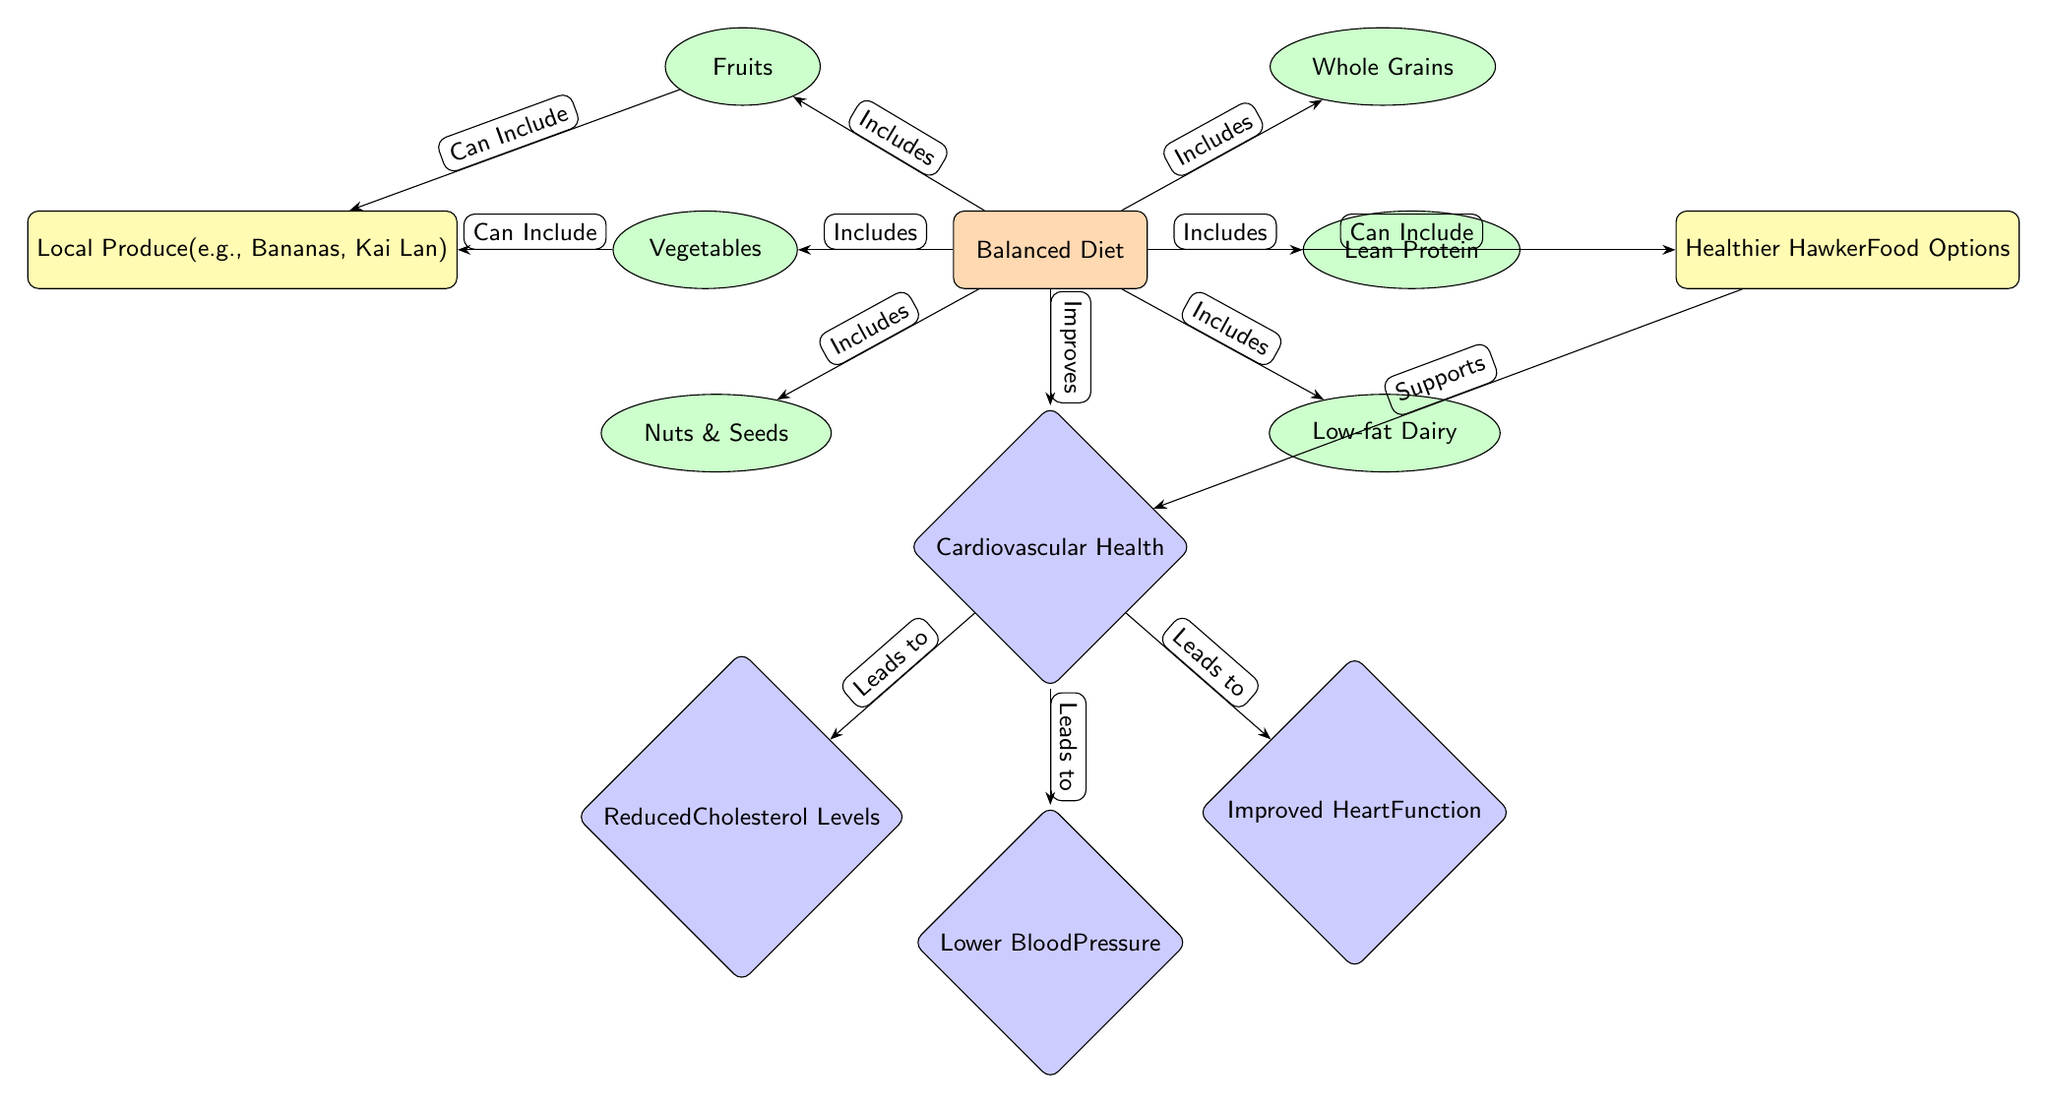What is the primary node in this diagram? The primary node is labeled "Balanced Diet," which is the central concept represented in the diagram.
Answer: Balanced Diet How many components are included in the balanced diet? There are six components listed directly under the "Balanced Diet" node: Vegetables, Fruits, Whole Grains, Lean Protein, Low-fat Dairy, and Nuts & Seeds.
Answer: 6 What effect does a balanced diet have on cardiovascular health? The diagram indicates that a balanced diet improves cardiovascular health, as shown by the connecting edge from the "Balanced Diet" node to the "Cardiovascular Health" node.
Answer: Improves Which component can include local produce? The diagram shows that local produce appears as a sub-node connected to both "Vegetables" and "Fruits," indicating that these food categories can include locally sourced options.
Answer: Vegetables, Fruits What are the three health effects of improved cardiovascular health? The diagram lists three specific health effects as outcomes of improved cardiovascular health: Reduced Cholesterol Levels, Lower Blood Pressure, and Improved Heart Function. This is evidenced by the connections from the "Cardiovascular Health" node.
Answer: Reduced Cholesterol Levels, Lower Blood Pressure, Improved Heart Function What type of food options can be included in a balanced diet aside from local produce? According to the diagram, healthier hawker food options are connected to the "Balanced Diet" node, indicating they are also included.
Answer: Healthier Hawker Food Options Which component can support cardiovascular health? The diagram shows an arrow from "Healthier Hawker Food Options" to "Cardiovascular Health," which indicates that these options can support cardiovascular health.
Answer: Healthier Hawker Food Options What leads to reduced cholesterol levels? Reduced cholesterol levels are a result of improved cardiovascular health, demonstrated by the arrow leading from the "Cardiovascular Health" node to the "Reduced Cholesterol Levels" node.
Answer: Improved Cardiovascular Health How do fruits and vegetables relate to local produce in the diagram? Both "Fruits" and "Vegetables" nodes have edges indicating that they "Can Include" local produce, showing their connection and dependency on locally sourced options.
Answer: Can Include 